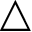<formula> <loc_0><loc_0><loc_500><loc_500>\bigtriangleup</formula> 